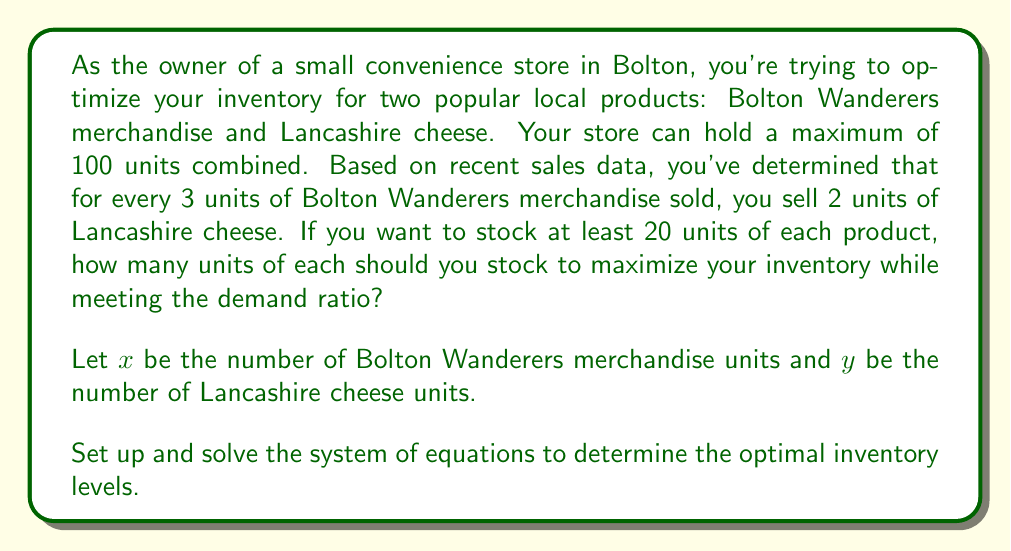Solve this math problem. Let's approach this step-by-step:

1) First, we need to set up our constraints:

   a) Total inventory constraint: $x + y \leq 100$
   b) Minimum stock constraint: $x \geq 20$ and $y \geq 20$
   c) Demand ratio constraint: $\frac{x}{3} = \frac{y}{2}$

2) From the demand ratio constraint, we can derive: $2x = 3y$

3) To maximize inventory, we want to use the full capacity, so we can change the inequality to an equality:
   $x + y = 100$

4) Now we have a system of two equations:
   $$\begin{cases}
   2x = 3y \\
   x + y = 100
   \end{cases}$$

5) From the first equation: $x = \frac{3y}{2}$

6) Substitute this into the second equation:
   $\frac{3y}{2} + y = 100$

7) Simplify:
   $\frac{3y}{2} + \frac{2y}{2} = 100$
   $\frac{5y}{2} = 100$

8) Solve for $y$:
   $y = \frac{200}{5} = 40$

9) Substitute back to find $x$:
   $x = 100 - y = 100 - 40 = 60$

10) Check if these values satisfy the minimum stock constraint:
    $x = 60 > 20$ and $y = 40 > 20$, so they do.

11) Verify the demand ratio:
    $\frac{60}{3} = 20$ and $\frac{40}{2} = 20$, so the ratio is correct.
Answer: The optimal inventory levels are 60 units of Bolton Wanderers merchandise and 40 units of Lancashire cheese. 